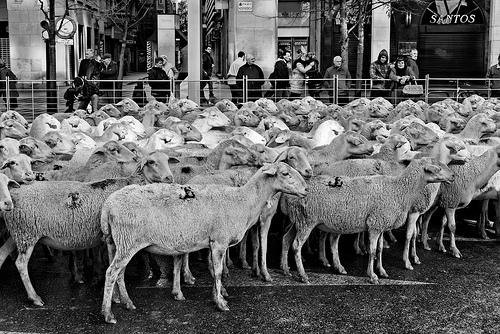Can you find any objects placed on the floor in the image? If so, describe them. There is a white arrow painted on the floor. Name one of the key features of the goats in the image. One key feature of the goats is a floppy ear on the side of the head. What is the primary focus of this image? Describe the scene and the main objects. The primary focus of the image is a herd of sheep and goats behind a fence, with people observing them and some having their arms resting on the fence. Please provide a short, concise description of the primary contents of the image. A herd of sheep and goats gathered behind a fence, with a group of people standing and observing them. What are the people in the image doing, and where are they located relative to the animals? The people are standing on the other side of the fence watching the sheep and goats. Identify and describe briefly any prominent object or feature that separates the animals from the people. A metal fence separates the animals and the people in the image. In the picture, are there any identifiable animals? If so, please list them. Yes, the image depicts sheep and goats. Provide a brief description of a few distinguishing features of the sheep in the image. The sheep have fluffy hair on their bodies, black tags, and some of them are looking towards the camera. Briefly describe an interaction between the people and the animals in the image. The people are watching and observing the sheep and goats from behind the fence. Is there any text, signage, or clock that can be seen in the background of the image? Yes, there is a white "Santos" sign and a clock in the background. What kind of jacket is the man wearing? Black jacket Describe the physical appearance of the standing white sheep. The sheep have white fluffy fur and are all standing in different positions within the pen. Can you see a rainbow in the background of the sky? No, it's not mentioned in the image. Assess the overall sentiment of the image. Neutral List the objects interacting with the fence. Group of people, arms resting, sheep and goats Ground the following expression: "black spot on the goat". X:86 Y:175 Width:47 Height:47 What does the white arrow painted on the floor signify? Direction or guidance Which animal has a black spot? The goat Analyze the interaction between the objects in the image. People are watching and interacting with sheep and goats behind a fence, while animals are standing and looking around in the pen. Find anything unusual in the image. Nothing unusual Determine the primary subject in the image. Sheep and goats Identify all the objects in the image. Herd of goats, fence, group of people, arms, floppy ear, goats standing on dirt, black spot, small black eye, head turned, fluffy hair, sheep, person standing behind sheep, white arrow, pillars, man wearing black jacket, person wearing jacket with hood, santos sign, clock, standing white sheep, metal fence, ear on sheep, support pillar, hooves, fur, purse, person wearing jacket with hood. Detect any text present in the image. White santos sign Identify the object attributes in the image. Fluffy hair on the body, small black eye, floppy ear, black spot, head turned, hooves, fur What is the primary purpose of the fence? To separate the animals from the people Describe the scene in the image. A herd of sheep and goats are standing in a large pen behind a metal fence, with people watching them from the other side. There are various objects and signs in the background. What is the position of the small black eye? X:282 Y:168 Width:8 Height:8 What is the relation between the people and the animals? The people are watching the animals behind the fence. Is there any text present in the image? If yes, where is it located? Yes, white santos sign located at X:426 Y:7 Width:55 Height:55 Evaluate the quality of the image. Good 